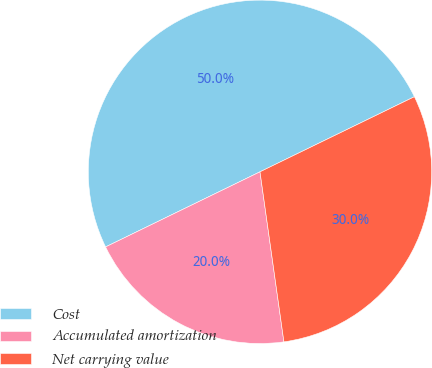<chart> <loc_0><loc_0><loc_500><loc_500><pie_chart><fcel>Cost<fcel>Accumulated amortization<fcel>Net carrying value<nl><fcel>50.0%<fcel>20.02%<fcel>29.98%<nl></chart> 